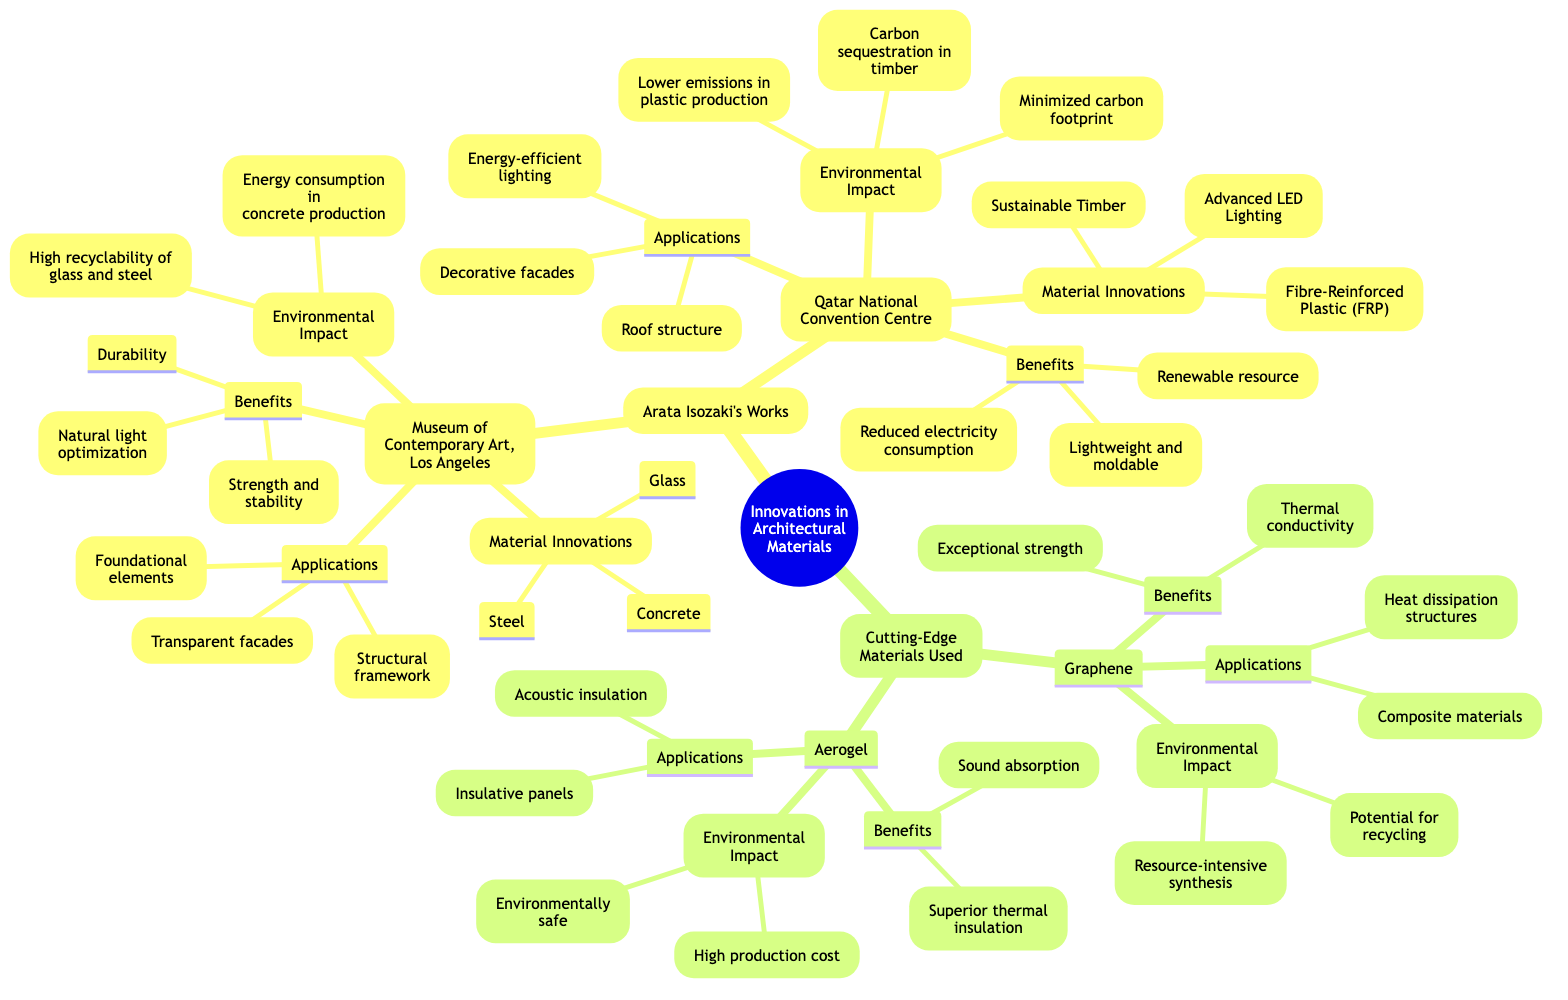What are the material innovations used in the Museum of Contemporary Art, Los Angeles? The diagram lists the material innovations specifically under the "Museum of Contemporary Art, Los Angeles" node, which includes Glass, Steel, and Concrete.
Answer: Glass, Steel, Concrete How many applications are associated with the Qatar National Convention Centre? By examining the "Applications" node under "Qatar National Convention Centre," we see three distinct applications: Roof structure, Decorative facades, and Energy-efficient lighting. Therefore, there are three applications in total.
Answer: 3 Which cutting-edge material is associated with superior thermal insulation? Looking at the "Benefits" section of the Aerogel node, it states "Superior thermal insulation" as one of its key attributes, indicating that Aerogel is the material in question.
Answer: Aerogel What is one environmental impact of using glass in architecture? Under the "Environmental Impact" section for the Museum of Contemporary Art, Los Angeles, it mentions "High recyclability of glass and steel," indicating this as a positive environmental aspect of using glass.
Answer: High recyclability What are the benefits of using fibre-reinforced plastic (FRP)? In the "Benefits" section of the Qatar National Convention Centre node, it lists: "Lightweight and moldable," which reflects the advantages provided by using fibre-reinforced plastic.
Answer: Lightweight and moldable Which cutting-edge material requires resource-intensive synthesis? When evaluating the "Environmental Impact" of the Graphene node, it states that it has "Resource-intensive synthesis," indicating that this material demands significant resources for its production.
Answer: Graphene What material is described as a renewable resource? The "Benefits" section for the Qatar National Convention Centre notes "Renewable resource," specifically identifying Sustainable Timber as the material associated with this benefit in architecture.
Answer: Sustainable Timber List one application of aerogel. The "Applications" section under the Aerogel node contains "Insulative panels" and "Acoustic insulation," indicating that one of its applications is insulative panels.
Answer: Insulative panels 